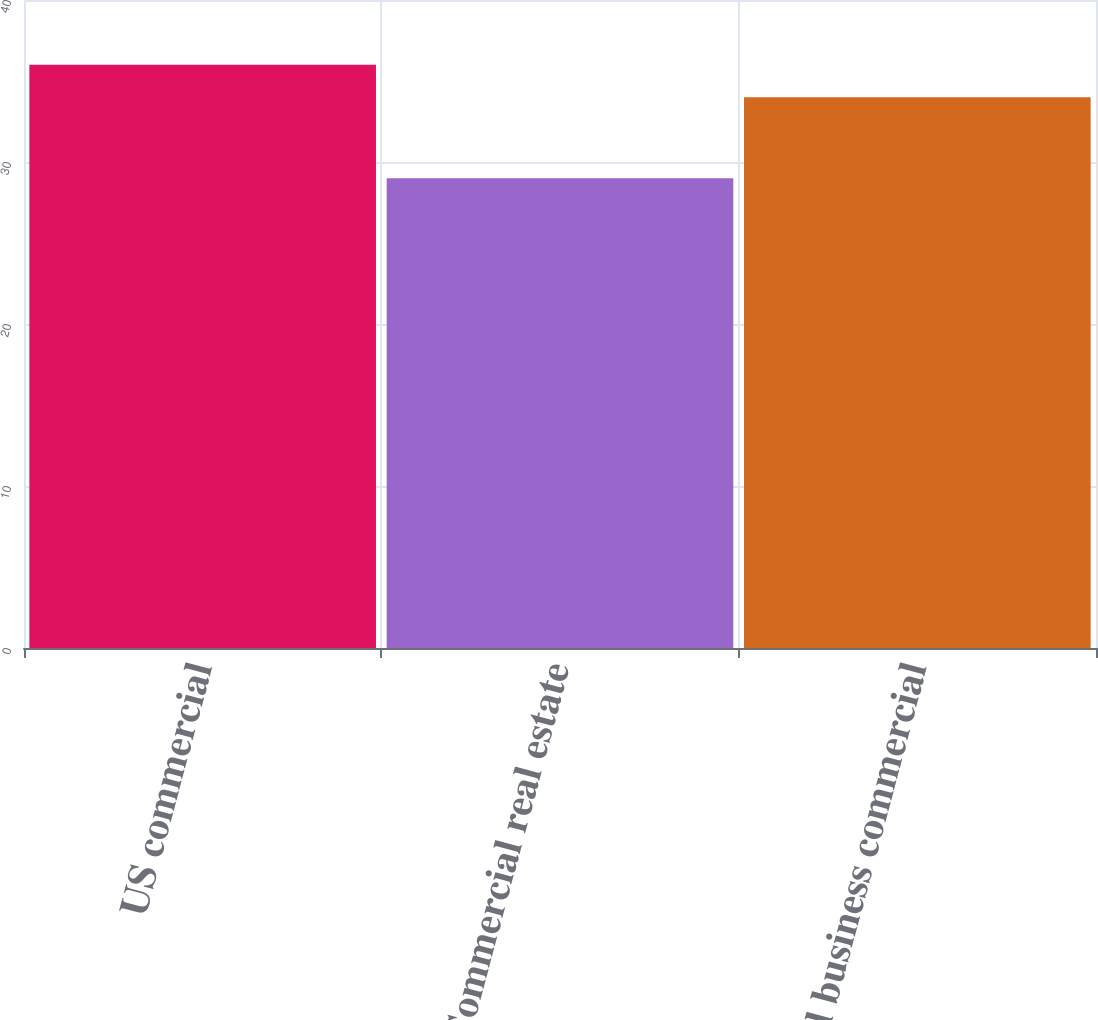<chart> <loc_0><loc_0><loc_500><loc_500><bar_chart><fcel>US commercial<fcel>Commercial real estate<fcel>US small business commercial<nl><fcel>36<fcel>29<fcel>34<nl></chart> 